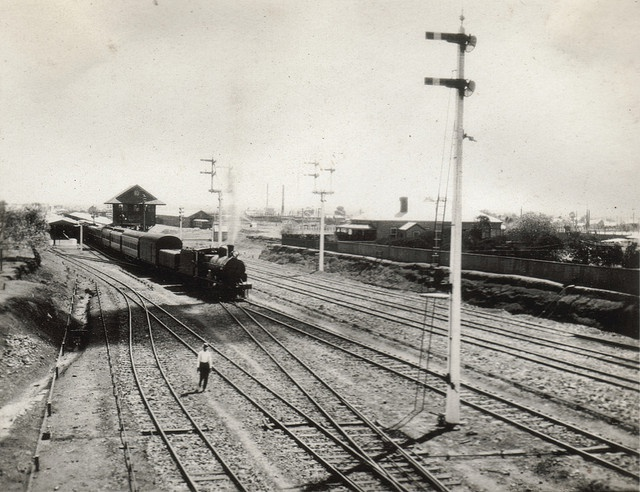Describe the objects in this image and their specific colors. I can see train in beige, black, darkgray, gray, and lightgray tones and people in beige, black, lightgray, darkgray, and gray tones in this image. 